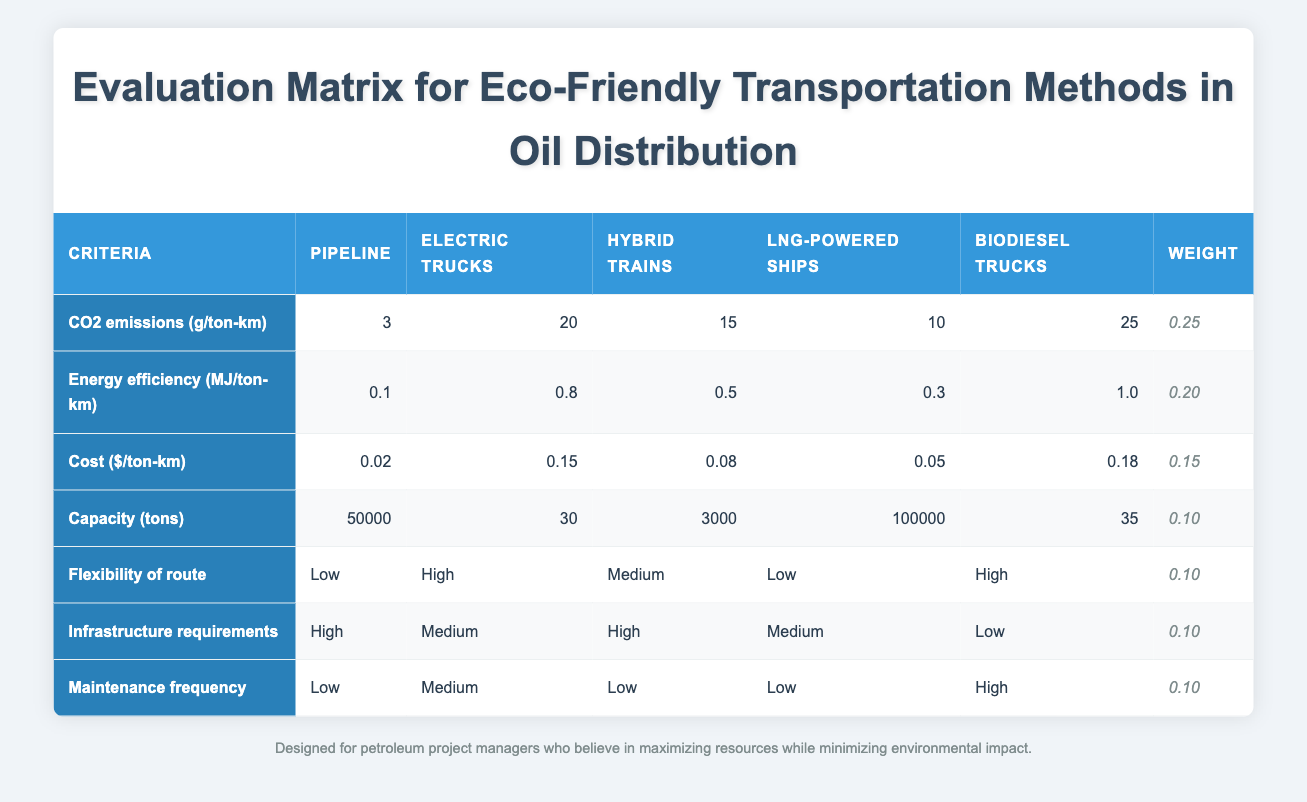What is the CO2 emission for electric trucks? The table provides the specific value of CO2 emissions for electric trucks directly under the "CO2 emissions (g/ton-km)" row, which is 20.
Answer: 20 Which transportation method has the highest energy efficiency? By examining the "Energy efficiency (MJ/ton-km)" row, we find that biodiesel trucks have the highest value of 1.0.
Answer: Biodiesel trucks What is the total capacity of LNG-powered ships compared to hybrid trains? LNG-powered ships have a capacity of 100000 tons, while hybrid trains have a capacity of 3000 tons. So, the total capacity when added together is 100000 + 3000 = 103000 tons.
Answer: 103000 tons Is the maintenance frequency for pipelines higher than for biodiesel trucks? The maintenance frequency for pipelines is listed as "Low," while for biodiesel trucks, it is "High." Since "Low" is not greater than "High," the statement is false.
Answer: No What is the average cost per ton-km for all transportation methods listed? The costs in the table are: 0.02, 0.15, 0.08, 0.05, and 0.18. First, we sum these values: 0.02 + 0.15 + 0.08 + 0.05 + 0.18 = 0.48. Then, since there are 5 methods, we divide by 5: 0.48 / 5 = 0.096.
Answer: 0.096 Which method has the highest flexibility of route? Looking at the "Flexibility of route" column, electric trucks and biodiesel trucks are rated as "High," while others are rated as "Low" or "Medium" meaning both electric and biodiesel trucks have the highest flexibility.
Answer: Electric trucks and biodiesel trucks Do LNG-powered ships require lower infrastructure compared to electric trucks? The table indicates that LNG-powered ships have "Medium" infrastructure requirements and electric trucks have "Medium" requirements as well. Thus, they have the same level of infrastructure requirements, making the statement false.
Answer: No What is the cost difference between hybrid trains and pipelines? The cost for hybrid trains is 0.08 and for pipelines is 0.02. The difference is calculated as 0.08 - 0.02 = 0.06.
Answer: 0.06 